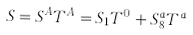Convert formula to latex. <formula><loc_0><loc_0><loc_500><loc_500>S = S ^ { A } T ^ { A } = S _ { 1 } T ^ { 0 } + S _ { 8 } ^ { a } T ^ { a }</formula> 